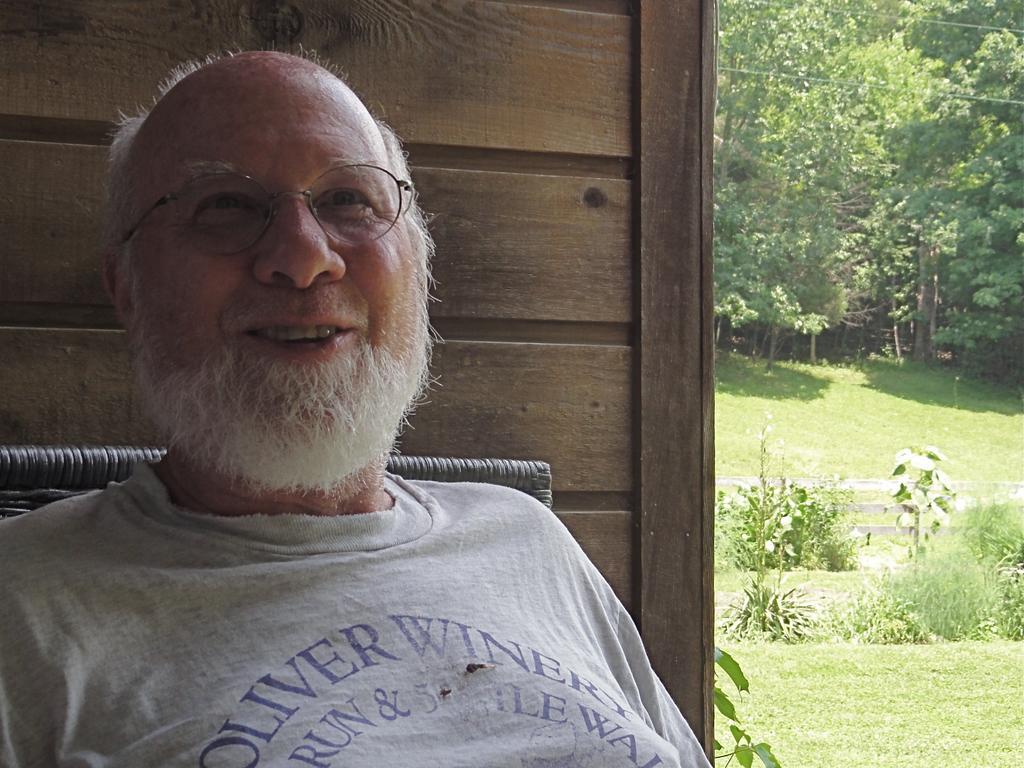Please provide a concise description of this image. In this picture we can see a man wore spectacles and smiling. At the back of him we can see an object and the wall. In the background we can see the grass, plants, fence and trees. 